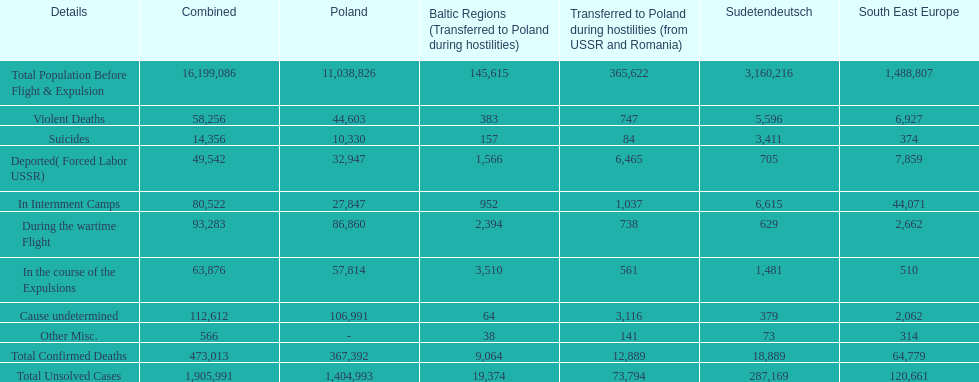What is the difference between suicides in poland and sudetendeutsch? 6919. 